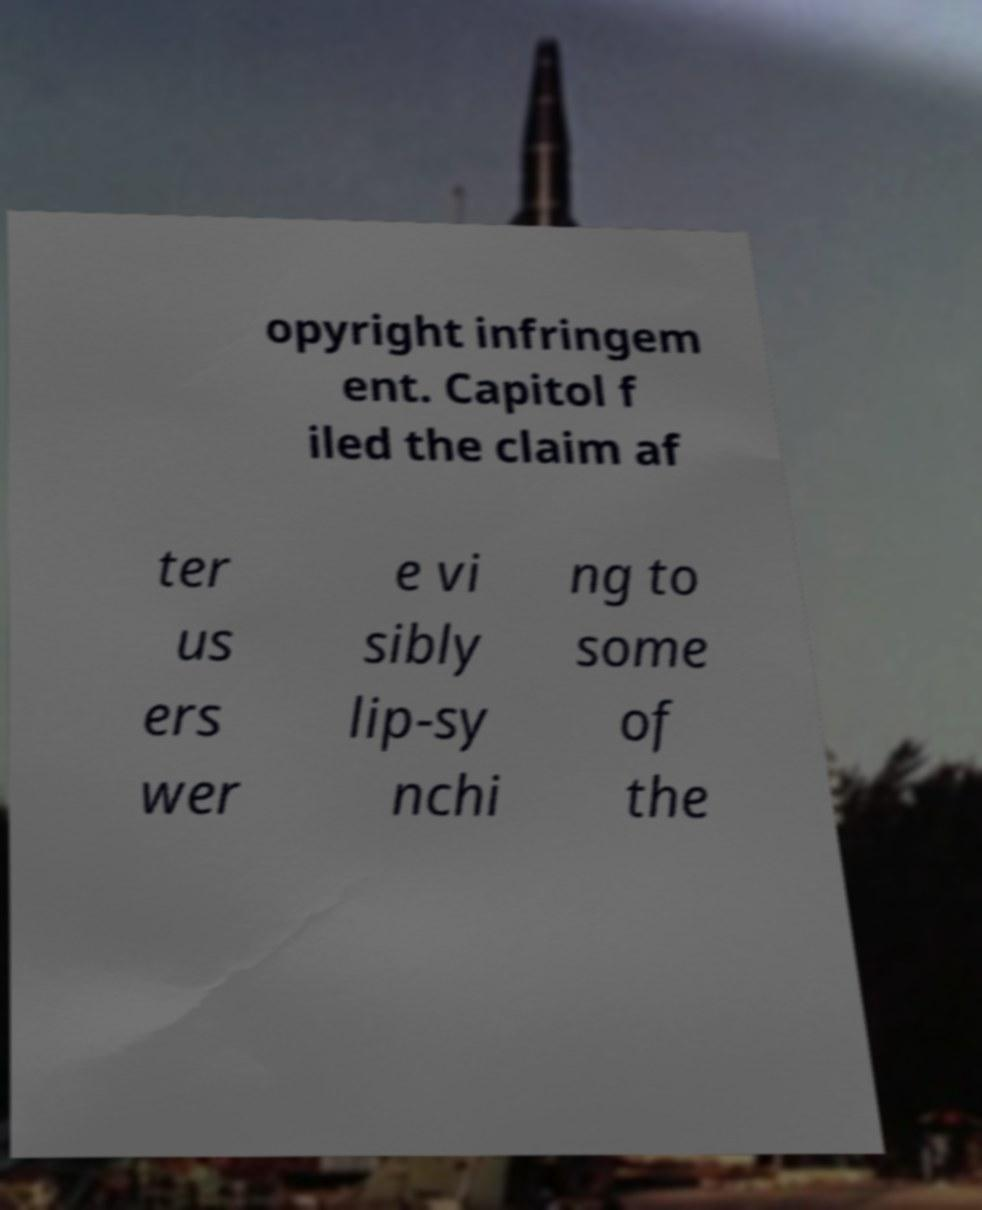Please identify and transcribe the text found in this image. opyright infringem ent. Capitol f iled the claim af ter us ers wer e vi sibly lip-sy nchi ng to some of the 